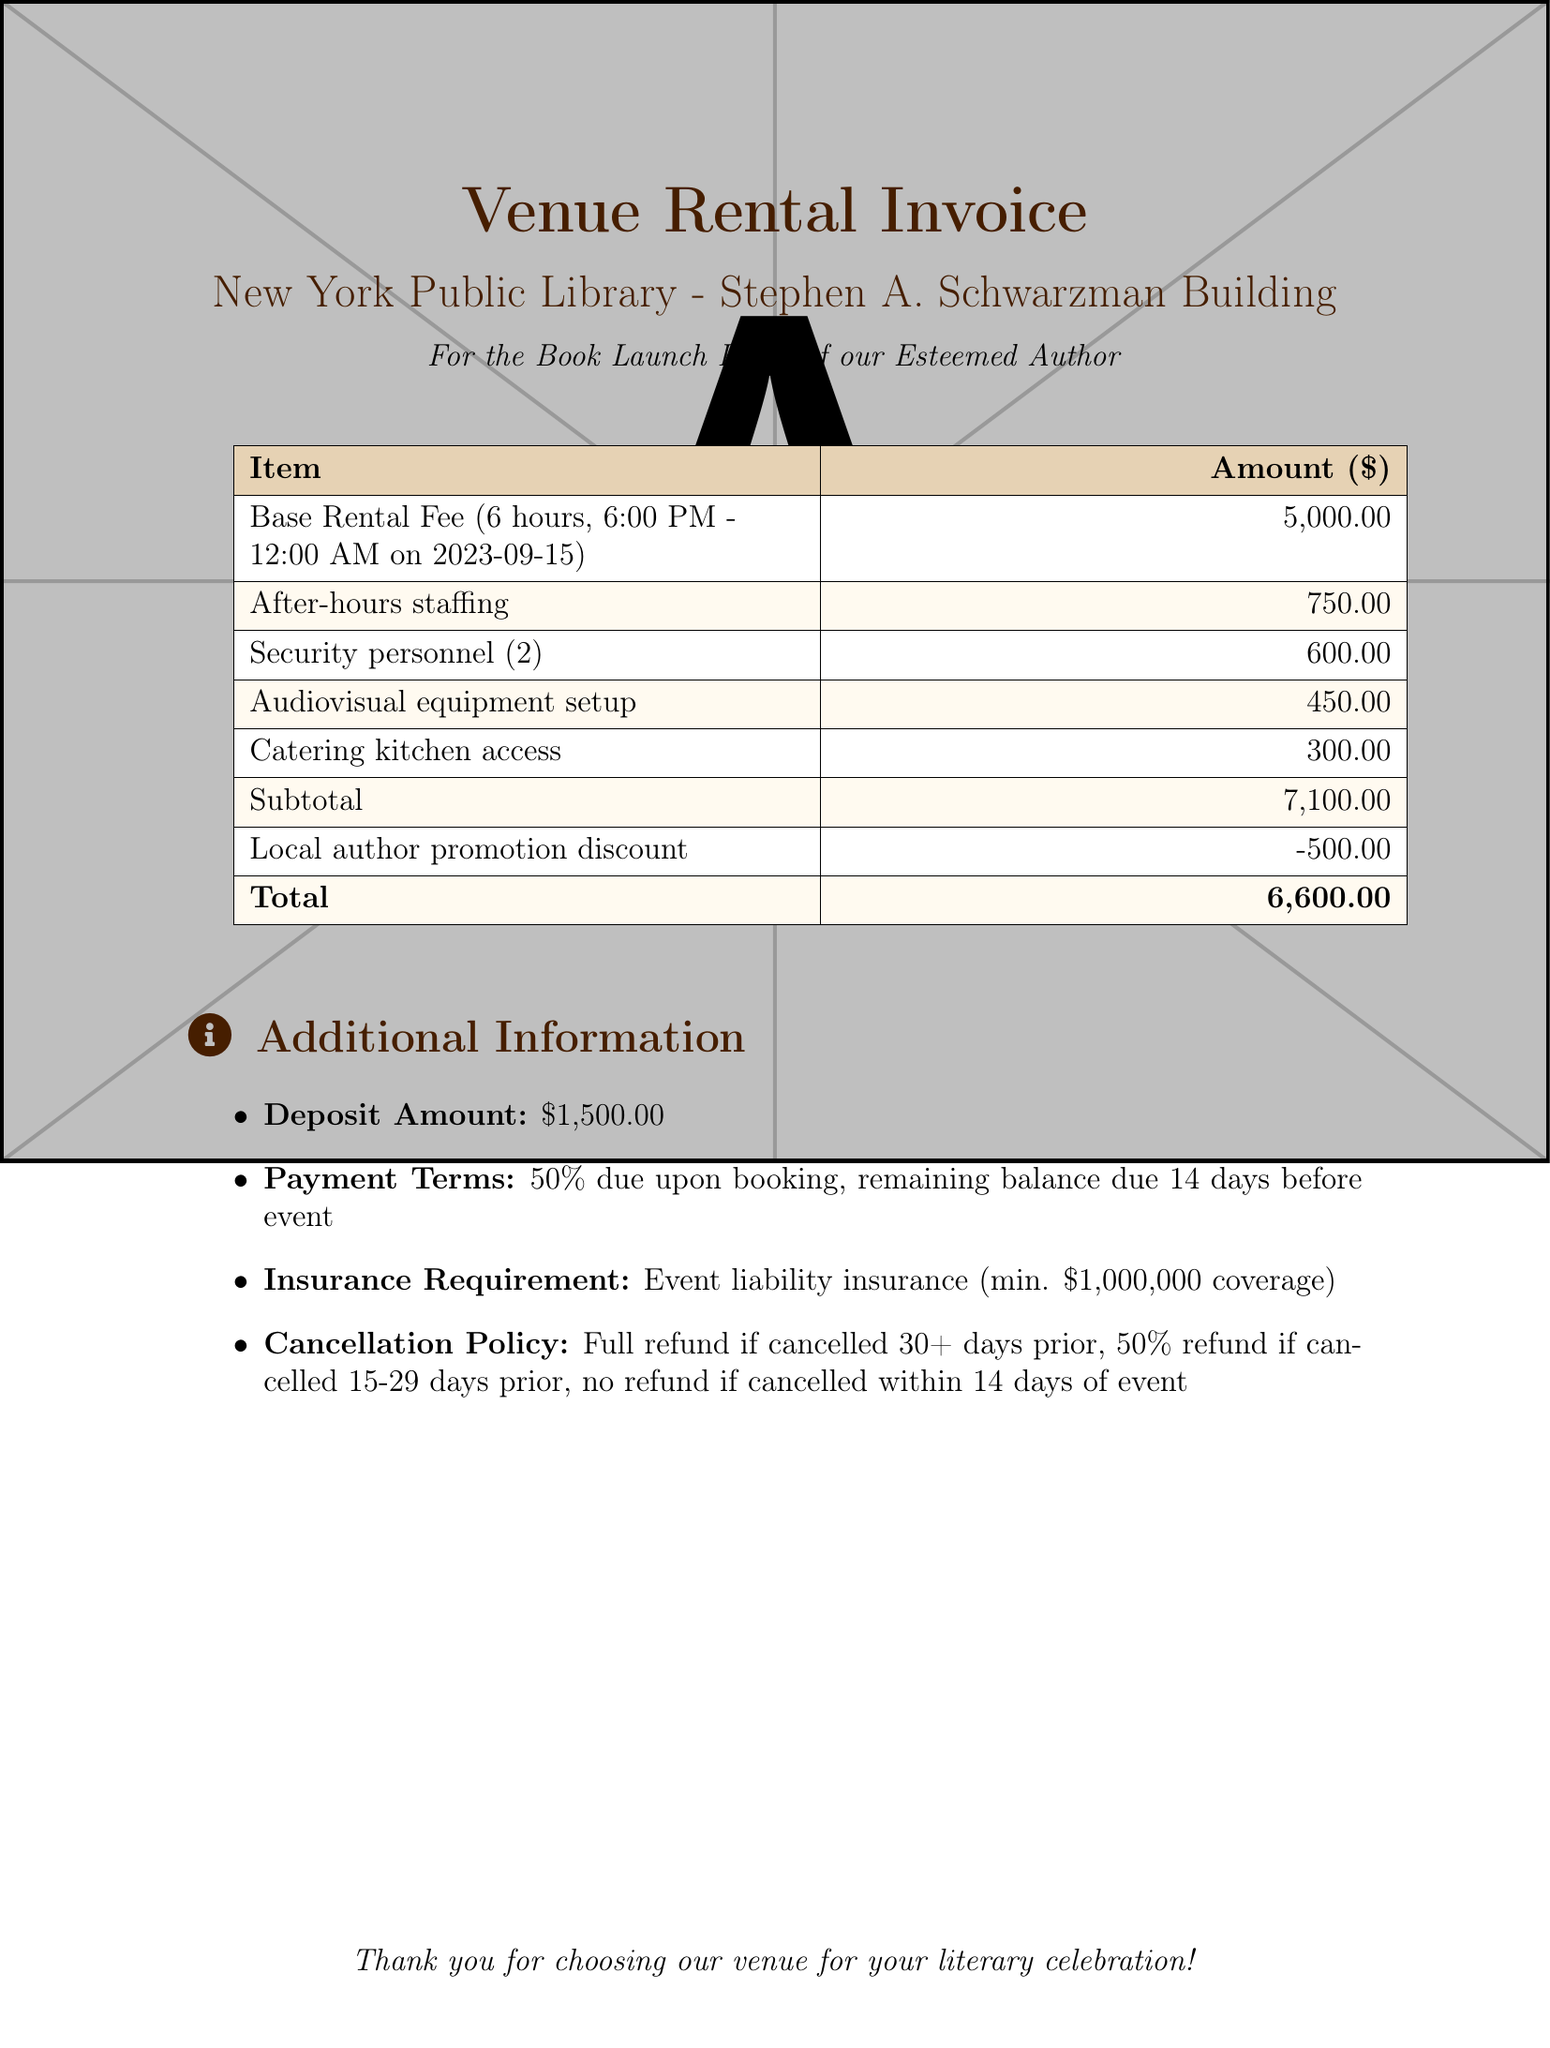What is the base rental fee? The base rental fee listed in the document is $5,000.00 for a duration of 6 hours.
Answer: $5,000.00 What is the date of the event? The event is scheduled for September 15, 2023, as mentioned in the base rental fee description.
Answer: 2023-09-15 How many hours is the venue rented for? The venue rental duration is stated as 6 hours in the document.
Answer: 6 hours What is the total amount due? The document specifies a total amount due, which is calculated after discounts.
Answer: $6,600.00 How much is the deposit required? The document lists the deposit amount required to secure the venue as $1,500.00.
Answer: $1,500.00 What discount is applied for local author promotion? The document mentions a discount applied to the invoice for local author promotion as $500.00.
Answer: -$500.00 How many security personnel are included in the bill? The invoice indicates that there are 2 security personnel included in the total fee.
Answer: 2 What is the insurance requirement for the event? The document specifies the insurance requirement as a minimum coverage of $1,000,000.
Answer: $1,000,000 What is the refund policy if the event is canceled 20 days prior? The cancellation policy states a 50% refund if canceled 15-29 days prior to the event.
Answer: 50% refund 